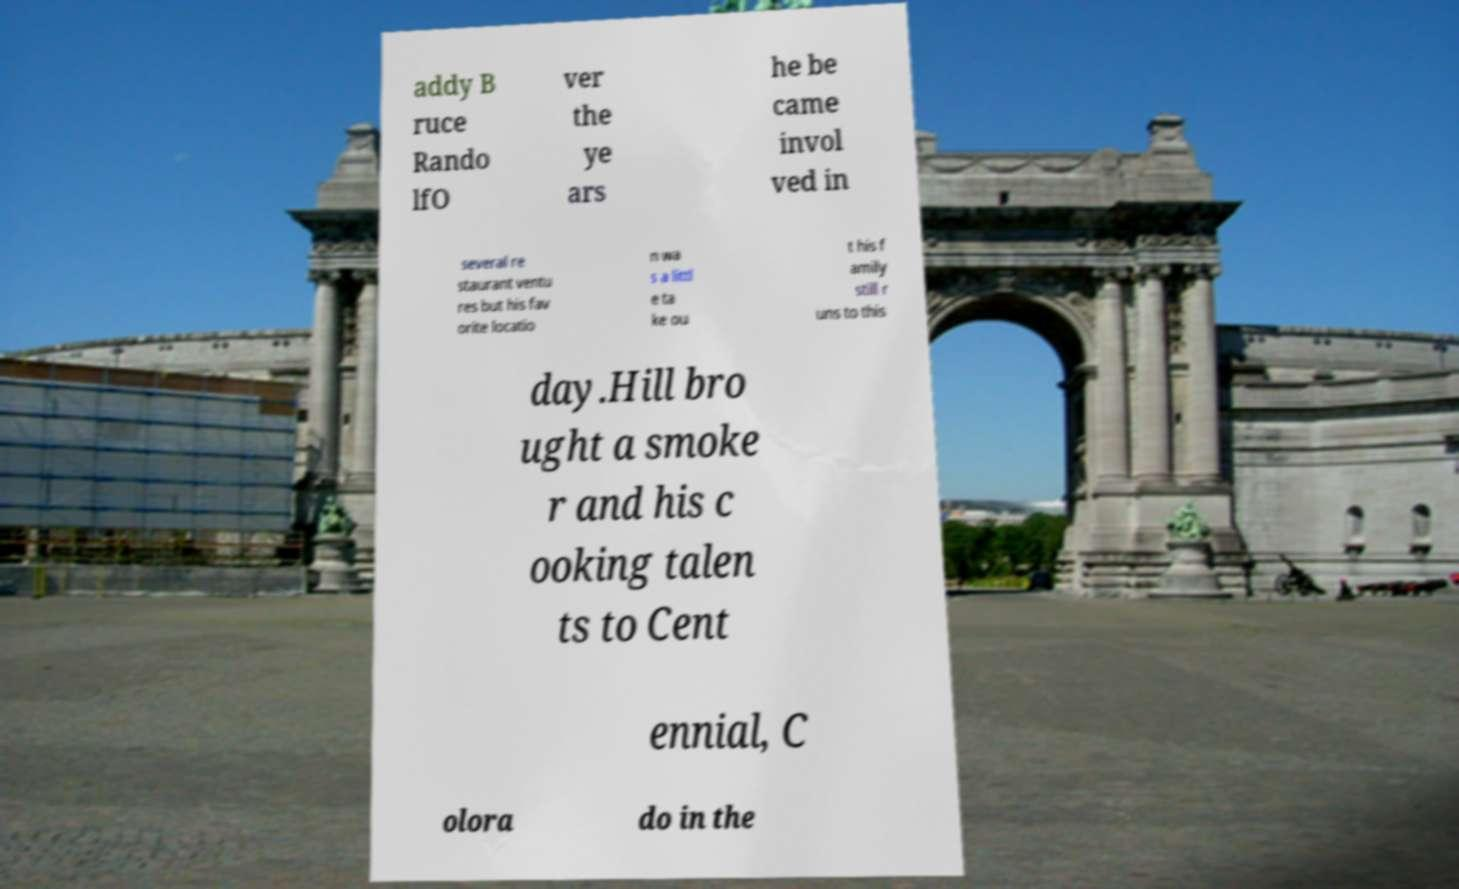Please identify and transcribe the text found in this image. addy B ruce Rando lfO ver the ye ars he be came invol ved in several re staurant ventu res but his fav orite locatio n wa s a littl e ta ke ou t his f amily still r uns to this day.Hill bro ught a smoke r and his c ooking talen ts to Cent ennial, C olora do in the 